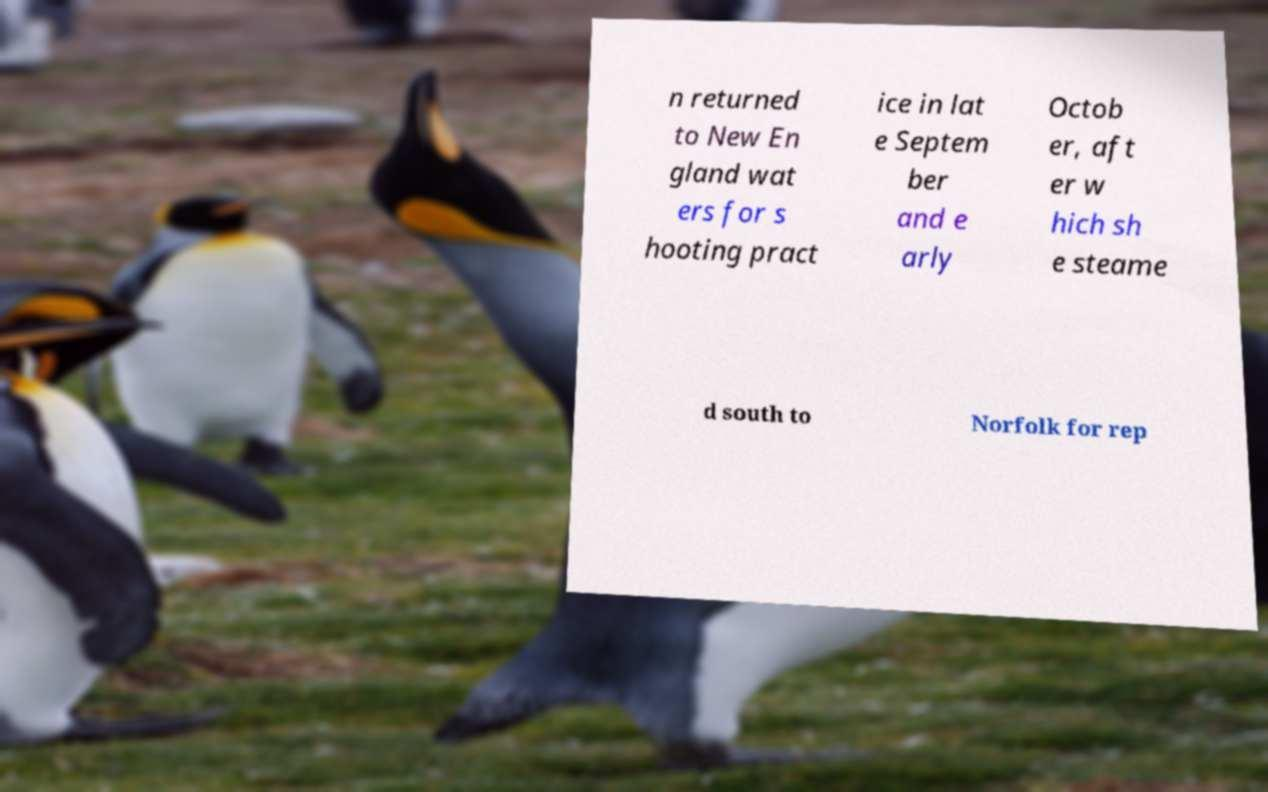There's text embedded in this image that I need extracted. Can you transcribe it verbatim? n returned to New En gland wat ers for s hooting pract ice in lat e Septem ber and e arly Octob er, aft er w hich sh e steame d south to Norfolk for rep 